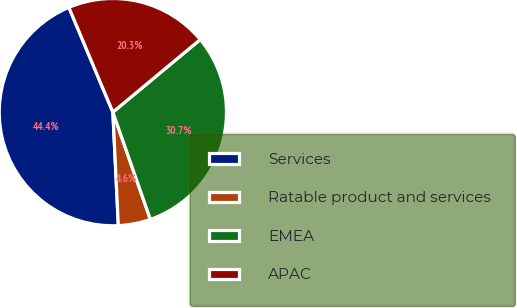<chart> <loc_0><loc_0><loc_500><loc_500><pie_chart><fcel>Services<fcel>Ratable product and services<fcel>EMEA<fcel>APAC<nl><fcel>44.44%<fcel>4.59%<fcel>30.68%<fcel>20.29%<nl></chart> 